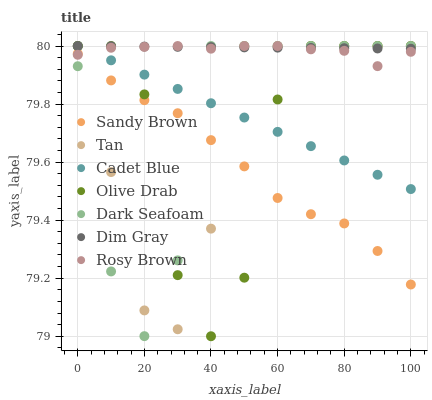Does Sandy Brown have the minimum area under the curve?
Answer yes or no. Yes. Does Dim Gray have the maximum area under the curve?
Answer yes or no. Yes. Does Rosy Brown have the minimum area under the curve?
Answer yes or no. No. Does Rosy Brown have the maximum area under the curve?
Answer yes or no. No. Is Cadet Blue the smoothest?
Answer yes or no. Yes. Is Olive Drab the roughest?
Answer yes or no. Yes. Is Rosy Brown the smoothest?
Answer yes or no. No. Is Rosy Brown the roughest?
Answer yes or no. No. Does Olive Drab have the lowest value?
Answer yes or no. Yes. Does Rosy Brown have the lowest value?
Answer yes or no. No. Does Olive Drab have the highest value?
Answer yes or no. Yes. Does Sandy Brown have the highest value?
Answer yes or no. No. Is Sandy Brown less than Dim Gray?
Answer yes or no. Yes. Is Dim Gray greater than Sandy Brown?
Answer yes or no. Yes. Does Dim Gray intersect Cadet Blue?
Answer yes or no. Yes. Is Dim Gray less than Cadet Blue?
Answer yes or no. No. Is Dim Gray greater than Cadet Blue?
Answer yes or no. No. Does Sandy Brown intersect Dim Gray?
Answer yes or no. No. 